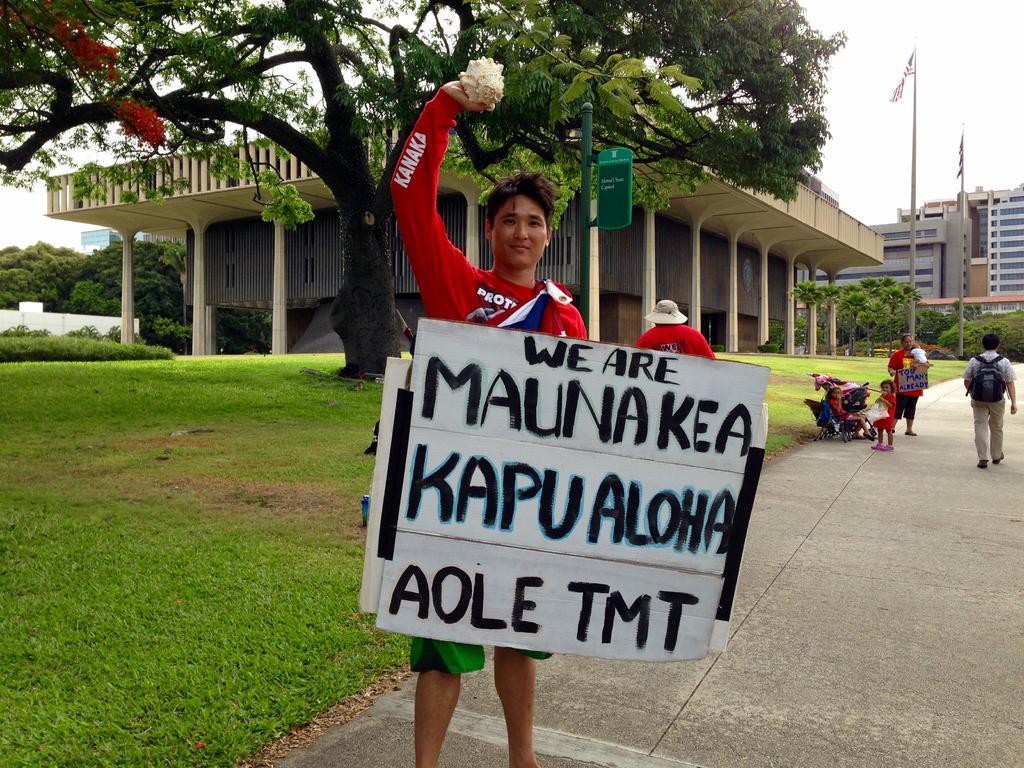Could you give a brief overview of what you see in this image? In this picture we can see a man in the red t shirt is holding a board and an object. Behind the people there are groups of people and a man is walking. Behind the people there are building, trees and a sky. 